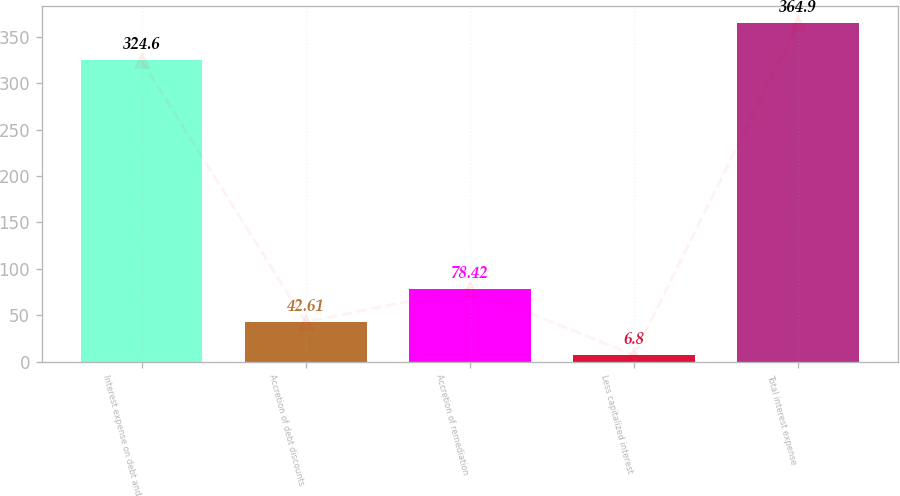Convert chart to OTSL. <chart><loc_0><loc_0><loc_500><loc_500><bar_chart><fcel>Interest expense on debt and<fcel>Accretion of debt discounts<fcel>Accretion of remediation<fcel>Less capitalized interest<fcel>Total interest expense<nl><fcel>324.6<fcel>42.61<fcel>78.42<fcel>6.8<fcel>364.9<nl></chart> 